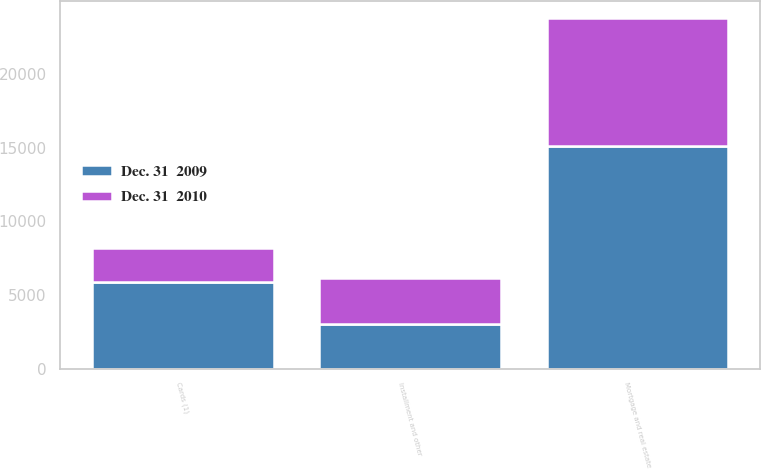Convert chart to OTSL. <chart><loc_0><loc_0><loc_500><loc_500><stacked_bar_chart><ecel><fcel>Mortgage and real estate<fcel>Cards (1)<fcel>Installment and other<nl><fcel>Dec. 31  2009<fcel>15140<fcel>5869<fcel>3015<nl><fcel>Dec. 31  2010<fcel>8654<fcel>2303<fcel>3128<nl></chart> 